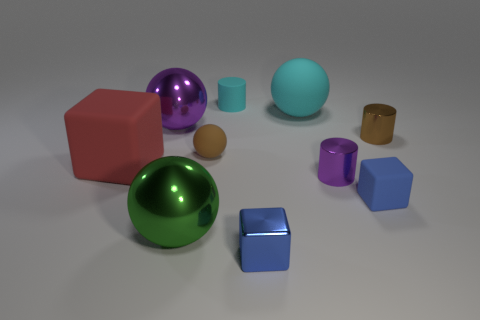How many small things are the same color as the big rubber ball?
Give a very brief answer. 1. What number of metal objects are either blue things or cylinders?
Give a very brief answer. 3. There is a cube right of the blue thing in front of the green object; what color is it?
Provide a succinct answer. Blue. Is the small cyan cylinder made of the same material as the blue cube to the left of the blue rubber block?
Offer a terse response. No. What color is the small shiny thing behind the big red object that is on the left side of the cyan rubber object on the right side of the tiny cyan thing?
Provide a short and direct response. Brown. Is there anything else that is the same shape as the big red object?
Give a very brief answer. Yes. Is the number of small shiny objects greater than the number of small spheres?
Offer a very short reply. Yes. How many matte objects are on the left side of the tiny metallic cube and behind the purple sphere?
Give a very brief answer. 1. There is a cylinder that is to the left of the big cyan matte sphere; how many big rubber objects are to the left of it?
Provide a succinct answer. 1. There is a matte block that is on the right side of the tiny cyan cylinder; is its size the same as the object behind the big cyan object?
Offer a very short reply. Yes. 